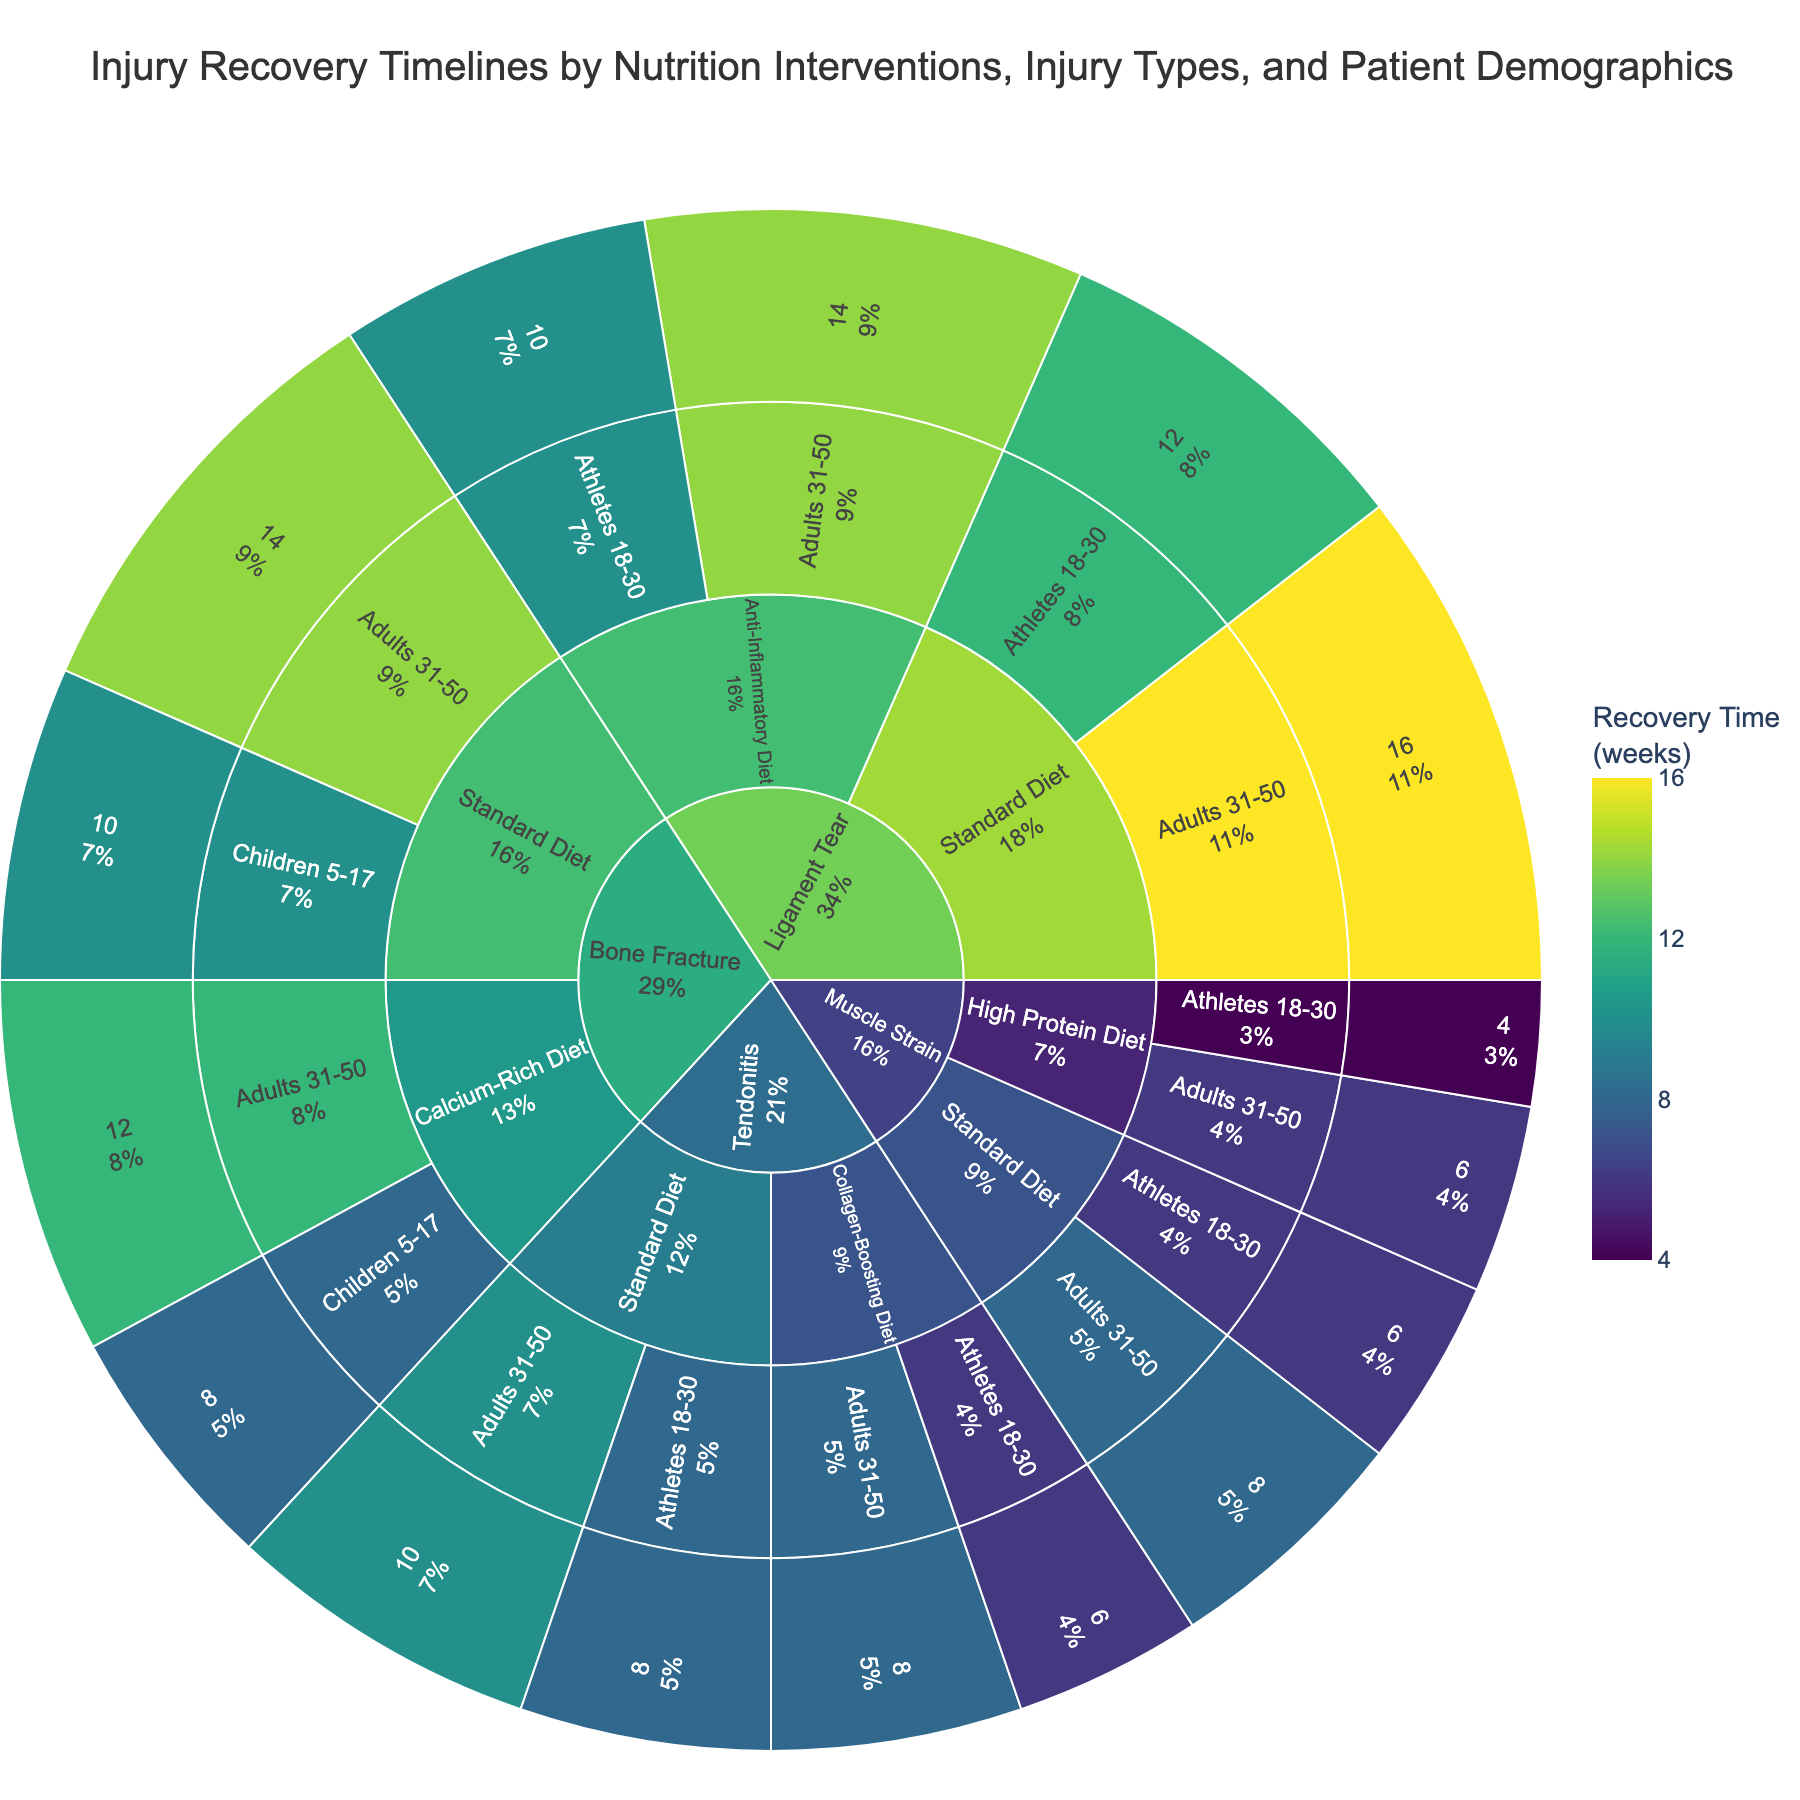What is the title of the sunburst plot? Look at the top or the center of the plot to find the title. It provides an overview of what the figure represents.
Answer: Injury Recovery Timelines by Nutrition Interventions, Injury Types, and Patient Demographics Which patient demographic group has the shortest recovery time for muscle strain with a high protein diet? Navigate through the sunburst chart starting from "Muscle Strain" -> "High Protein Diet" -> "Patient Demographics". Look for the shortest recovery time among the groups.
Answer: Athletes 18-30 What are the recovery times for bone fractures among children 5-17 on a standard diet and a calcium-rich diet? Find "Bone Fracture", then look into both "Standard Diet" and "Calcium-Rich Diet". Then, check the recovery times associated with "Children 5-17".
Answer: 10 weeks, 8 weeks Look at "Tendonitis" and compare the recovery times of different nutrition interventions (Collagen-Boosting Diet vs Standard Diet) for the targeted demographic. The one with a shorter recovery time is the answer. Collagen-Boosting Diet
Answer: 8 weeks Check within "Ligament Tear" for "Athletes 18-30" and compare their recovery times under the "Anti-Inflammatory Diet" and "Standard Diet". The one with the shorter recovery time provides your answer. Anti-Inflammatory Diet
Answer: 10 weeks What demographic experiences the longest recovery time for any injury type? Explore the outermost edge of the sunburst plot to identify the longest recovery time, then trace back to the associated demographic.
Answer: Adults 31-50 with Ligament Tear on Standard Diet How does the recovery time for muscle strains compare between athletes aged 18-30 on a standard diet and adults aged 31-50 on a high protein diet? Navigate to "Muscle Strain", then identify the recovery times for athletes aged 18-30 on a "Standard Diet" and adults aged 31-50 on a "High Protein Diet". Compare these two values directly.
Answer: Standard Diet (6 weeks), High Protein Diet (6 weeks) What's the average recovery time for bone fractures among adults aged 31-50 on both diets? Identify the recovery times for adults aged 31-50 with "Bone Fracture" on both diets, sum these times, and divide by the number of values.
Answer: (12 weeks + 14 weeks) / 2 = 13 weeks Which injury type has the most diverse range of recovery times across all demographics and diets? Check each injury category and observe the variety of recovery times associated with different demographics and diets. The injury type with the widest range of recovery times is the answer.
Answer: Ligament Tear 